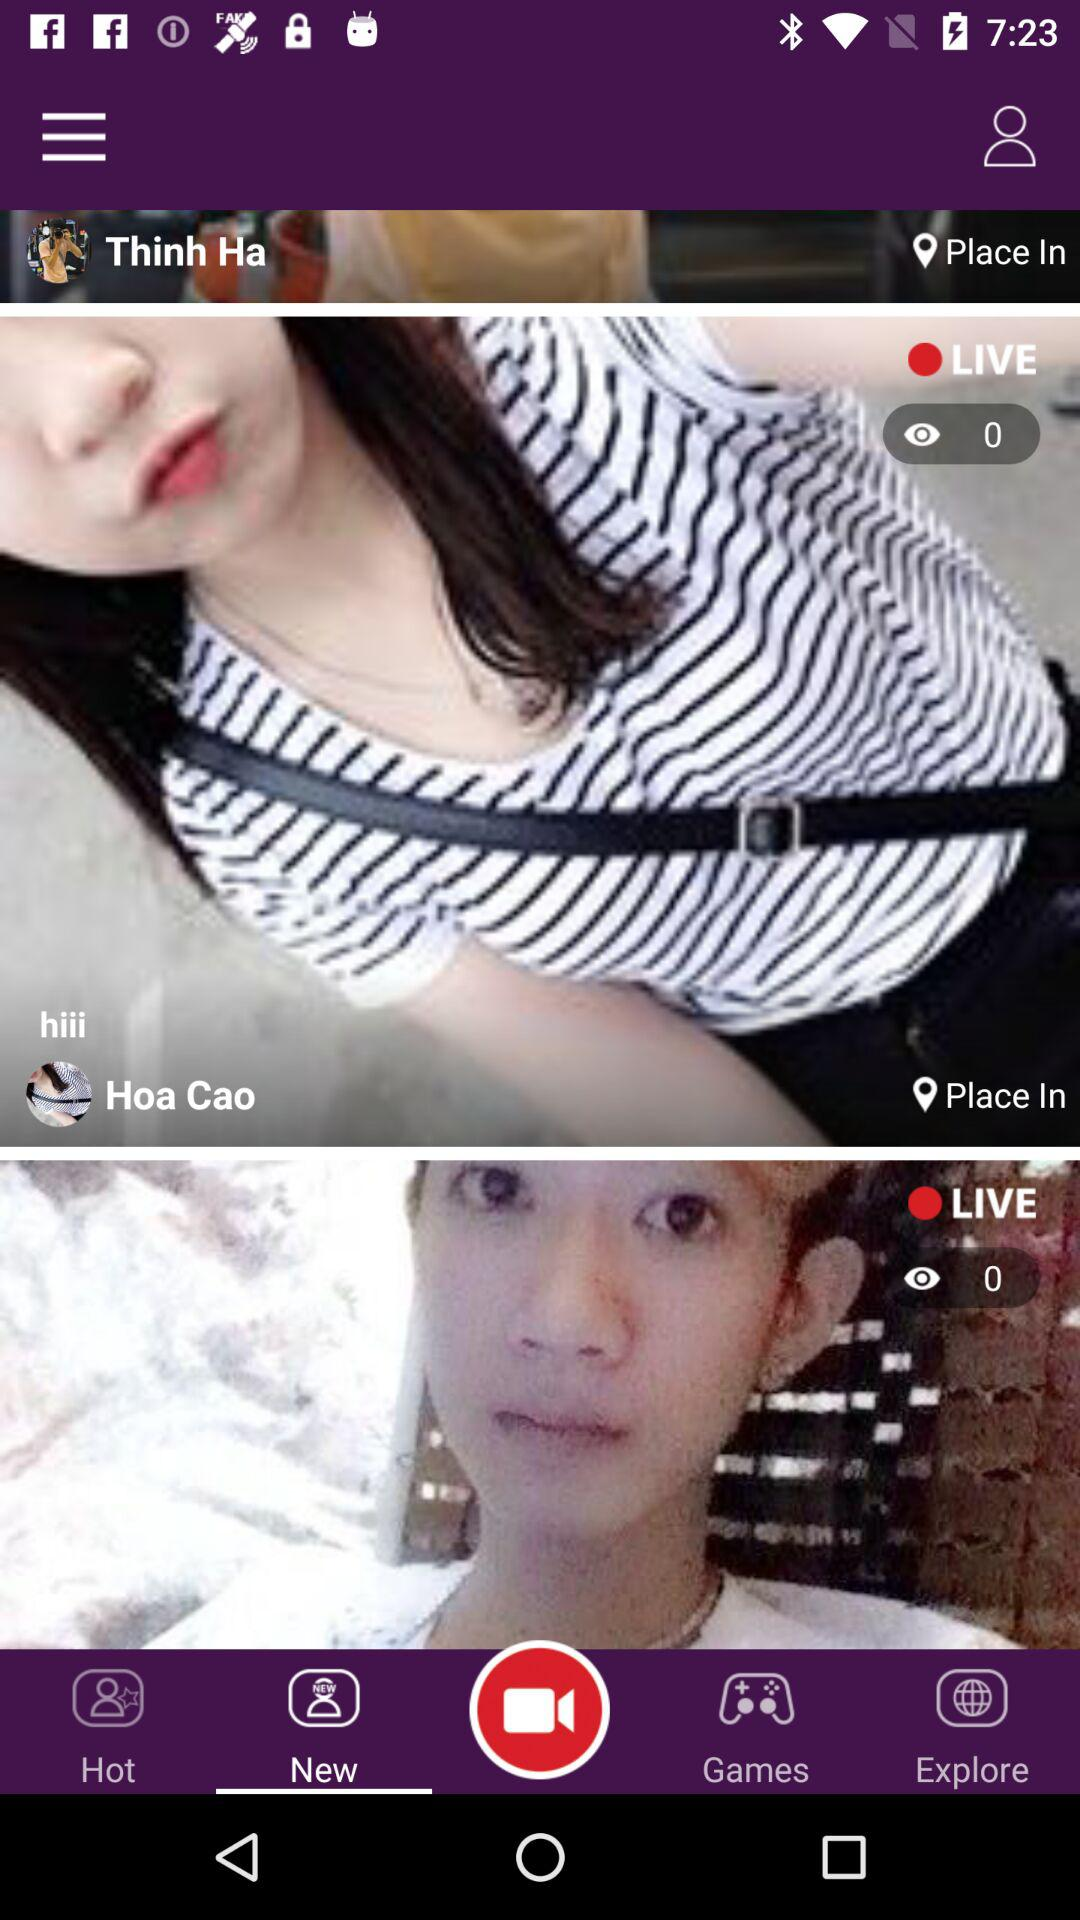What tab am i using? The tab that i am using is "New". 